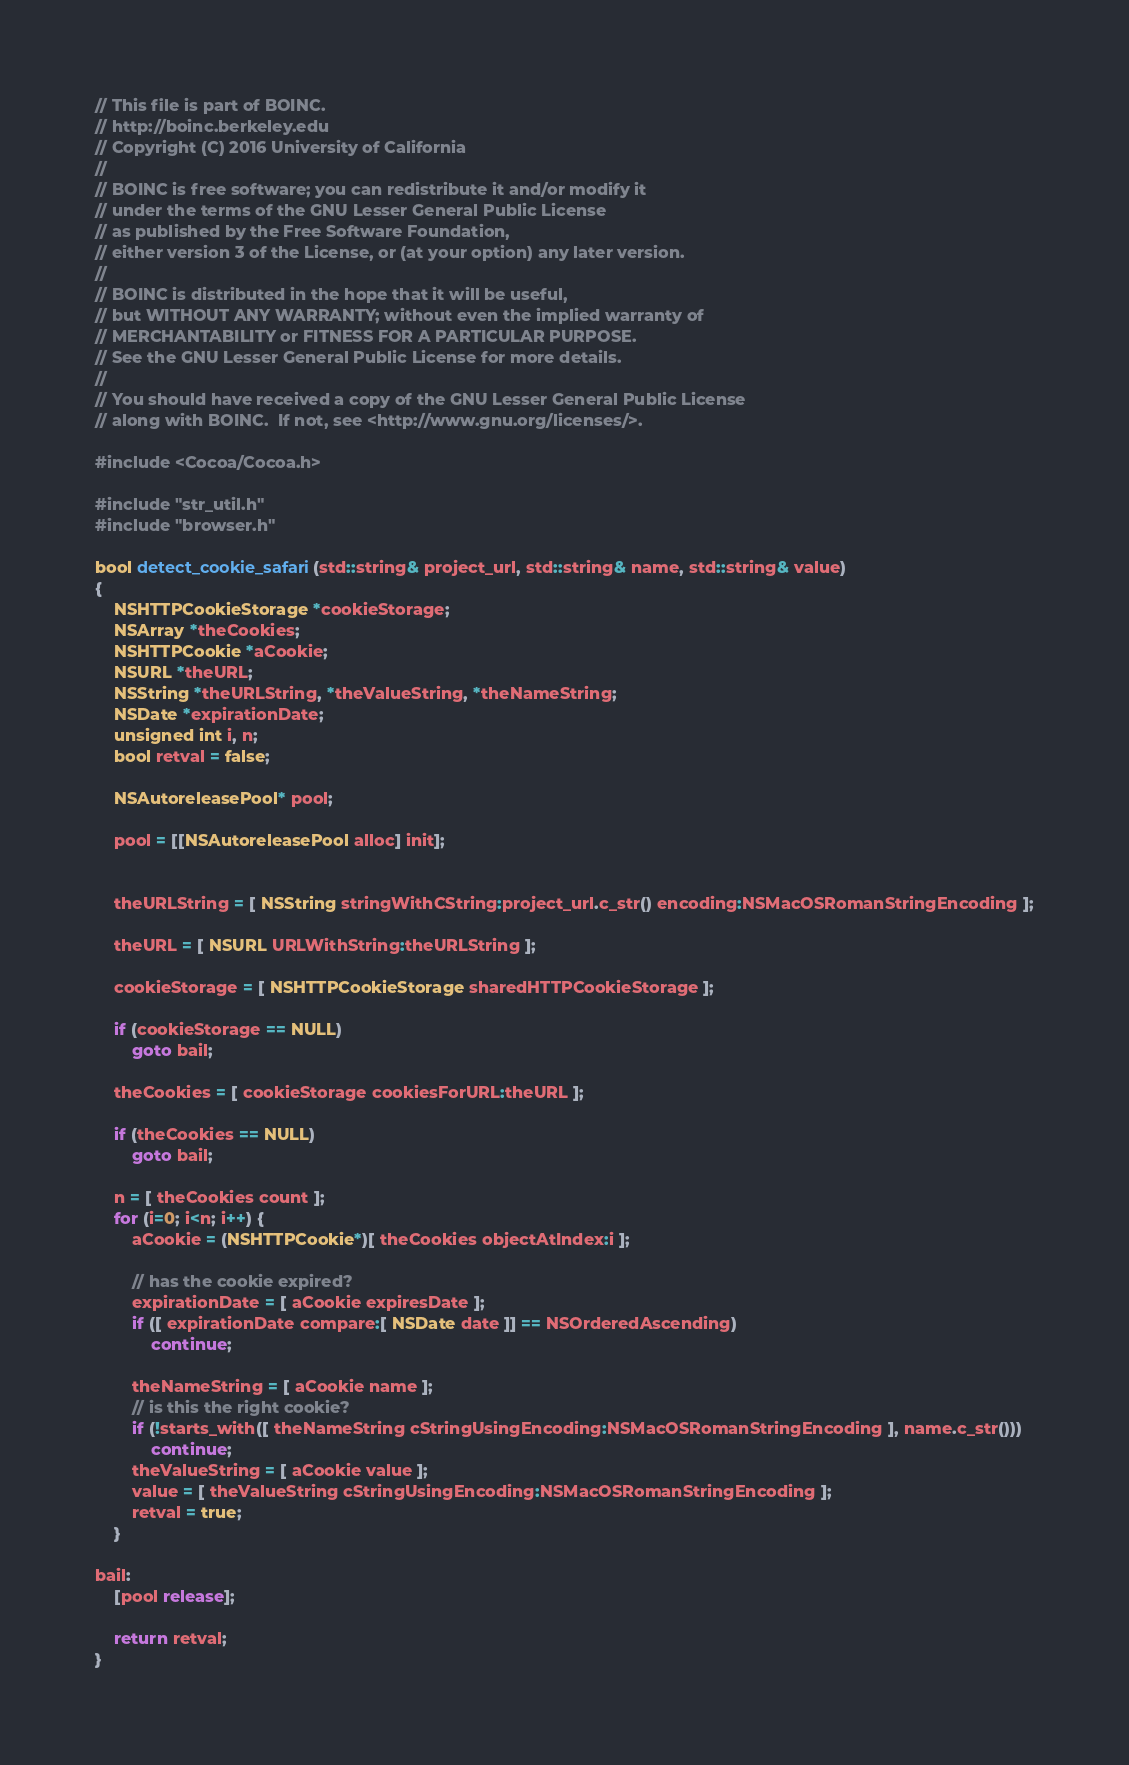<code> <loc_0><loc_0><loc_500><loc_500><_ObjectiveC_>// This file is part of BOINC.
// http://boinc.berkeley.edu
// Copyright (C) 2016 University of California
//
// BOINC is free software; you can redistribute it and/or modify it
// under the terms of the GNU Lesser General Public License
// as published by the Free Software Foundation,
// either version 3 of the License, or (at your option) any later version.
//
// BOINC is distributed in the hope that it will be useful,
// but WITHOUT ANY WARRANTY; without even the implied warranty of
// MERCHANTABILITY or FITNESS FOR A PARTICULAR PURPOSE.
// See the GNU Lesser General Public License for more details.
//
// You should have received a copy of the GNU Lesser General Public License
// along with BOINC.  If not, see <http://www.gnu.org/licenses/>.

#include <Cocoa/Cocoa.h>

#include "str_util.h"
#include "browser.h"

bool detect_cookie_safari(std::string& project_url, std::string& name, std::string& value)
{    
    NSHTTPCookieStorage *cookieStorage;
    NSArray *theCookies;
    NSHTTPCookie *aCookie;
    NSURL *theURL;
    NSString *theURLString, *theValueString, *theNameString;
    NSDate *expirationDate;
    unsigned int i, n;
    bool retval = false;

    NSAutoreleasePool* pool;
    
    pool = [[NSAutoreleasePool alloc] init];
    
    
    theURLString = [ NSString stringWithCString:project_url.c_str() encoding:NSMacOSRomanStringEncoding ];
    
    theURL = [ NSURL URLWithString:theURLString ];

    cookieStorage = [ NSHTTPCookieStorage sharedHTTPCookieStorage ];
    
    if (cookieStorage == NULL)
        goto bail;
    
    theCookies = [ cookieStorage cookiesForURL:theURL ];

    if (theCookies == NULL)
        goto bail;

    n = [ theCookies count ];
    for (i=0; i<n; i++) {
        aCookie = (NSHTTPCookie*)[ theCookies objectAtIndex:i ];

        // has the cookie expired?
        expirationDate = [ aCookie expiresDate ];
        if ([ expirationDate compare:[ NSDate date ]] == NSOrderedAscending)
            continue;
            
        theNameString = [ aCookie name ];
        // is this the right cookie?
        if (!starts_with([ theNameString cStringUsingEncoding:NSMacOSRomanStringEncoding ], name.c_str()))
            continue;
        theValueString = [ aCookie value ];
        value = [ theValueString cStringUsingEncoding:NSMacOSRomanStringEncoding ];
        retval = true;
    }

bail:
    [pool release];

    return retval;
}
</code> 